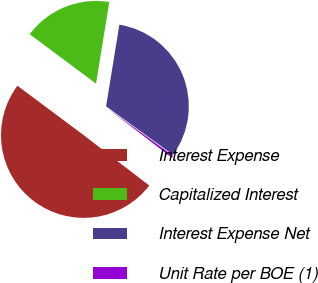Convert chart. <chart><loc_0><loc_0><loc_500><loc_500><pie_chart><fcel>Interest Expense<fcel>Capitalized Interest<fcel>Interest Expense Net<fcel>Unit Rate per BOE (1)<nl><fcel>49.78%<fcel>17.37%<fcel>32.42%<fcel>0.44%<nl></chart> 